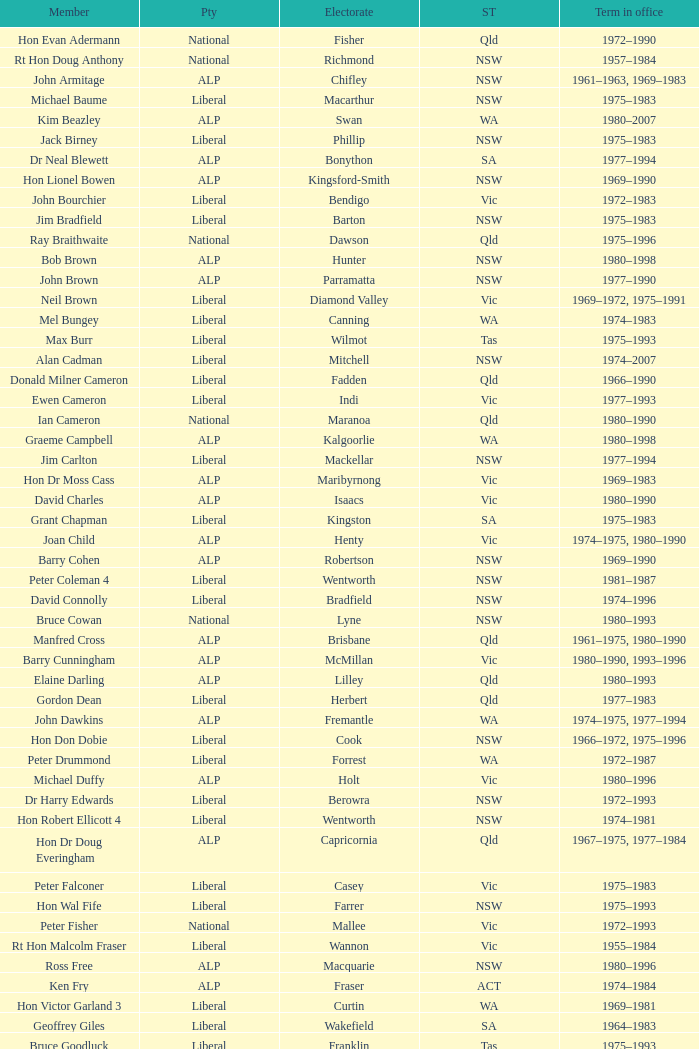What party is Mick Young a member of? ALP. 